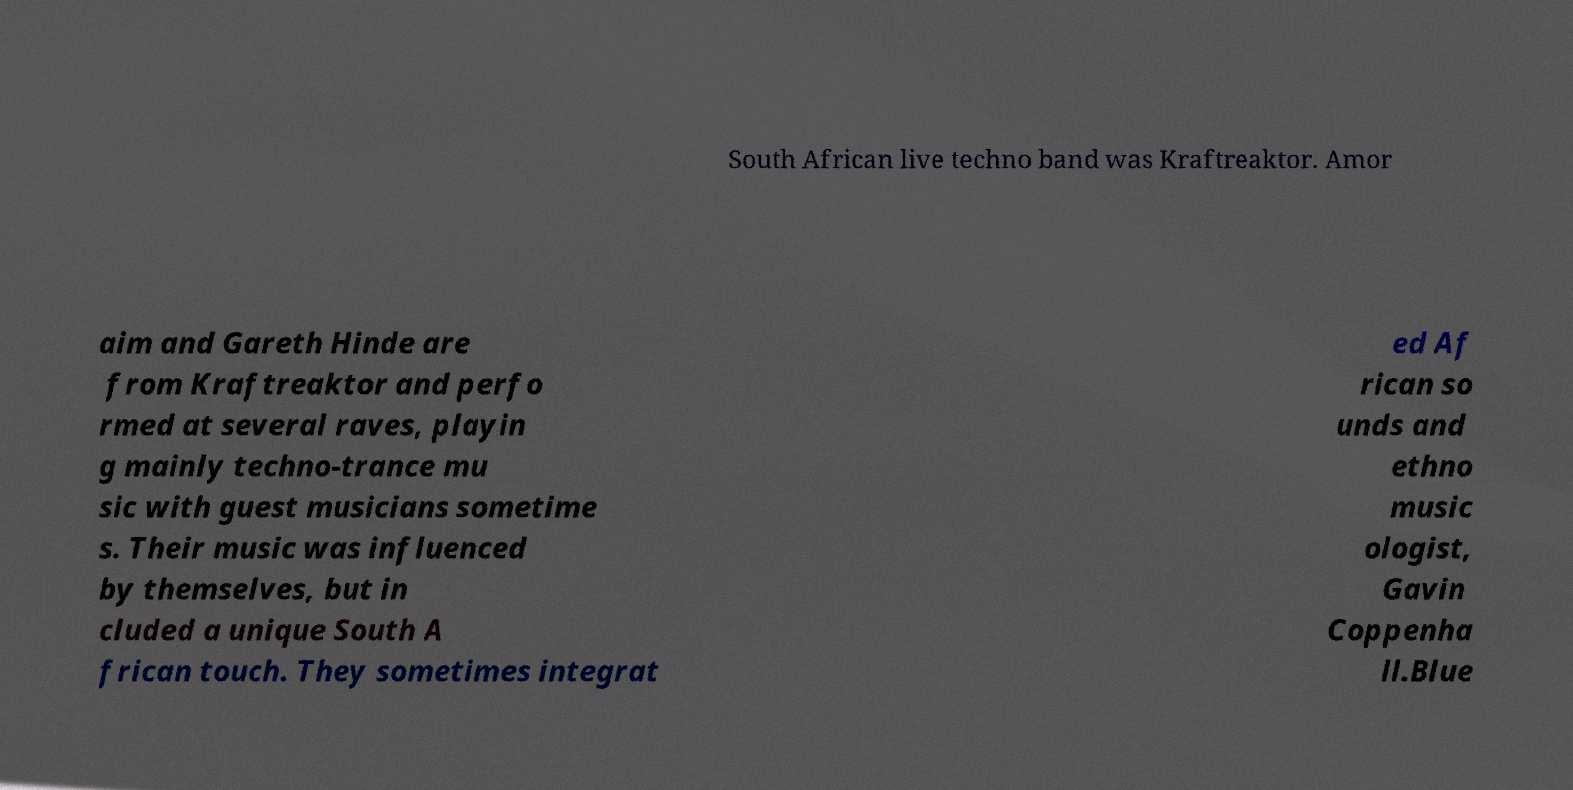Can you read and provide the text displayed in the image?This photo seems to have some interesting text. Can you extract and type it out for me? South African live techno band was Kraftreaktor. Amor aim and Gareth Hinde are from Kraftreaktor and perfo rmed at several raves, playin g mainly techno-trance mu sic with guest musicians sometime s. Their music was influenced by themselves, but in cluded a unique South A frican touch. They sometimes integrat ed Af rican so unds and ethno music ologist, Gavin Coppenha ll.Blue 